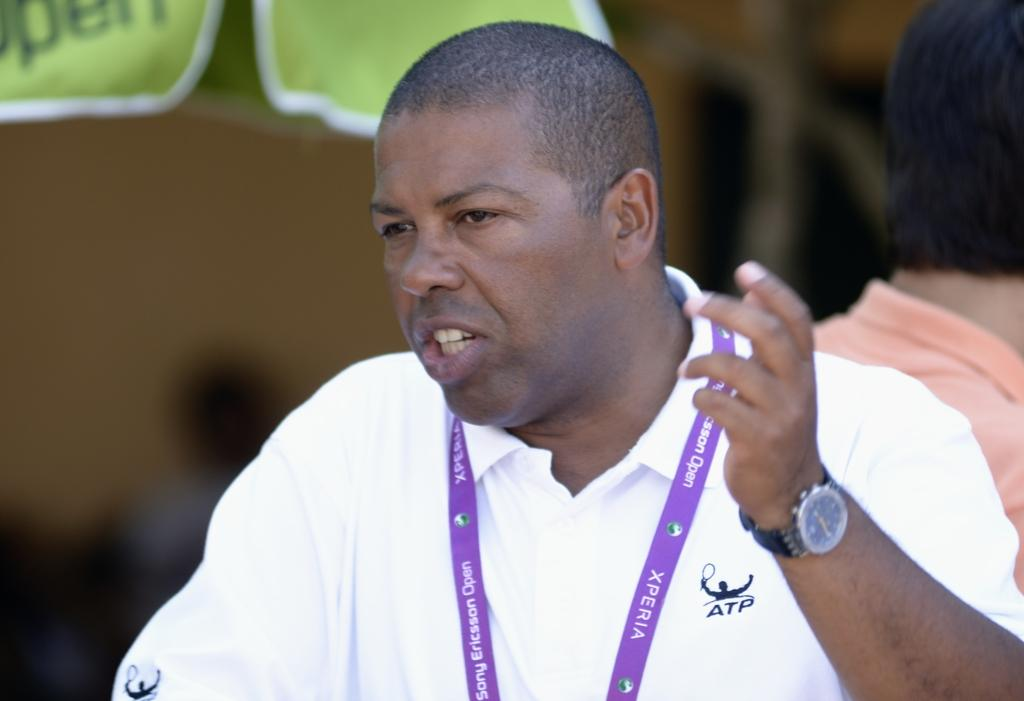How many people are in the image? There are two people in the image. What is the man wearing on his wrist? The man is wearing a watch. What else is the man wearing? The man is wearing an ID tag. Can you describe the background of the image? The background of the image is blurry. What can be seen in the background of the image? There are objects visible in the background of the image. What type of toothpaste is being used by the woman in the image? There is no toothpaste present in the image, and the woman's actions are not described. 